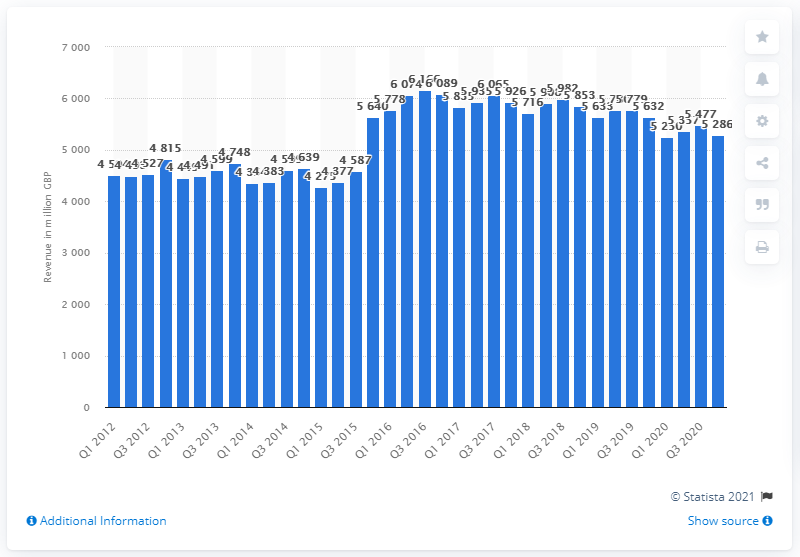Specify some key components in this picture. BT's total revenue generated in the fourth quarter of 2020/21 was £5,286. 